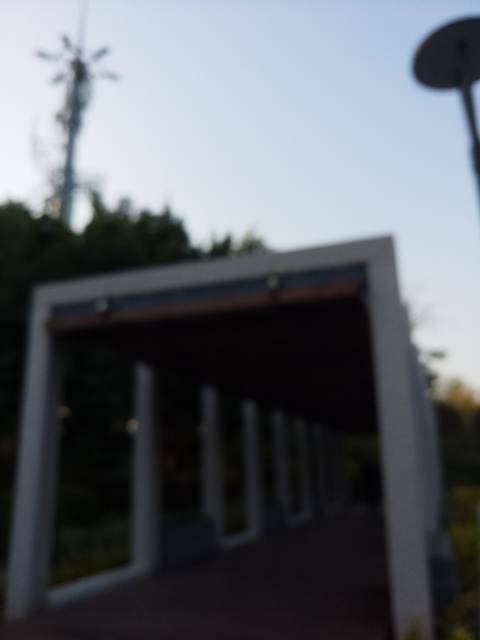What emotions or moods does the blurriness of this image evoke? The blurriness of the image may evoke feelings of mystery or ambiguity. It could also produce a sense of calmness or dreaminess, as details are obscured and the viewer is left to fill in the blanks with their imagination. Some might find it frustrating, as it deprives the viewer of clear information about the scene. 